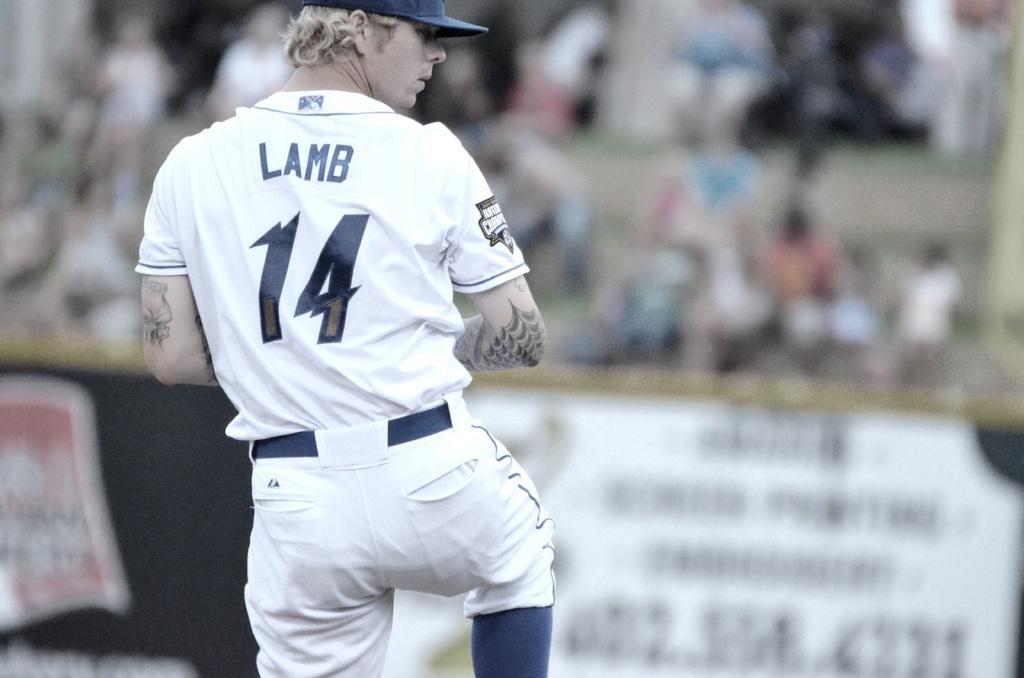<image>
Relay a brief, clear account of the picture shown. A baseball player with Lamb 14 on the back of his shirt. 